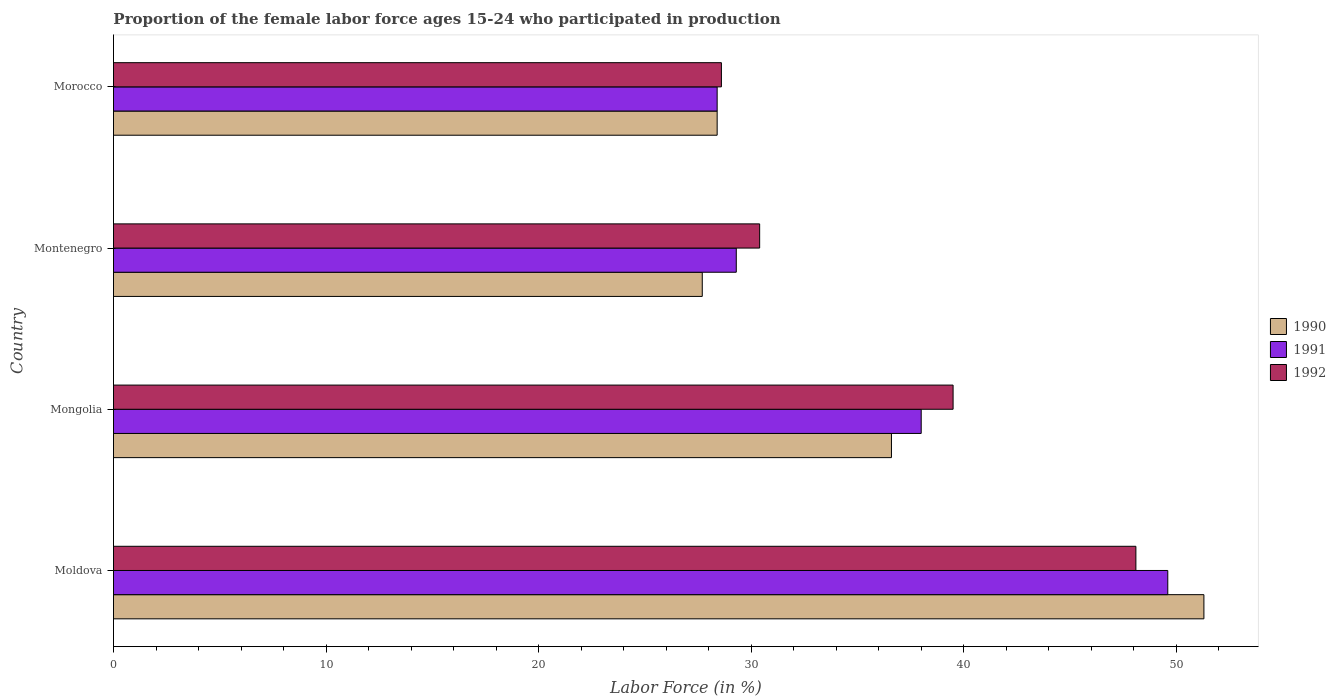Are the number of bars per tick equal to the number of legend labels?
Provide a short and direct response. Yes. Are the number of bars on each tick of the Y-axis equal?
Your answer should be compact. Yes. How many bars are there on the 1st tick from the bottom?
Your response must be concise. 3. What is the label of the 1st group of bars from the top?
Your answer should be compact. Morocco. In how many cases, is the number of bars for a given country not equal to the number of legend labels?
Keep it short and to the point. 0. What is the proportion of the female labor force who participated in production in 1990 in Mongolia?
Your answer should be very brief. 36.6. Across all countries, what is the maximum proportion of the female labor force who participated in production in 1992?
Your answer should be very brief. 48.1. Across all countries, what is the minimum proportion of the female labor force who participated in production in 1990?
Your response must be concise. 27.7. In which country was the proportion of the female labor force who participated in production in 1992 maximum?
Ensure brevity in your answer.  Moldova. In which country was the proportion of the female labor force who participated in production in 1992 minimum?
Keep it short and to the point. Morocco. What is the total proportion of the female labor force who participated in production in 1991 in the graph?
Your answer should be very brief. 145.3. What is the difference between the proportion of the female labor force who participated in production in 1992 in Mongolia and that in Montenegro?
Offer a very short reply. 9.1. What is the difference between the proportion of the female labor force who participated in production in 1992 in Mongolia and the proportion of the female labor force who participated in production in 1990 in Morocco?
Your response must be concise. 11.1. What is the average proportion of the female labor force who participated in production in 1990 per country?
Keep it short and to the point. 36. What is the difference between the proportion of the female labor force who participated in production in 1991 and proportion of the female labor force who participated in production in 1990 in Montenegro?
Make the answer very short. 1.6. In how many countries, is the proportion of the female labor force who participated in production in 1990 greater than 10 %?
Make the answer very short. 4. What is the ratio of the proportion of the female labor force who participated in production in 1992 in Montenegro to that in Morocco?
Provide a succinct answer. 1.06. What is the difference between the highest and the second highest proportion of the female labor force who participated in production in 1990?
Your response must be concise. 14.7. What is the difference between the highest and the lowest proportion of the female labor force who participated in production in 1992?
Your answer should be compact. 19.5. In how many countries, is the proportion of the female labor force who participated in production in 1990 greater than the average proportion of the female labor force who participated in production in 1990 taken over all countries?
Your answer should be very brief. 2. What does the 2nd bar from the bottom in Mongolia represents?
Keep it short and to the point. 1991. How many bars are there?
Provide a short and direct response. 12. How many countries are there in the graph?
Give a very brief answer. 4. Does the graph contain any zero values?
Ensure brevity in your answer.  No. Does the graph contain grids?
Offer a terse response. No. Where does the legend appear in the graph?
Your answer should be compact. Center right. What is the title of the graph?
Your answer should be compact. Proportion of the female labor force ages 15-24 who participated in production. Does "1988" appear as one of the legend labels in the graph?
Provide a succinct answer. No. What is the Labor Force (in %) of 1990 in Moldova?
Offer a very short reply. 51.3. What is the Labor Force (in %) in 1991 in Moldova?
Offer a terse response. 49.6. What is the Labor Force (in %) of 1992 in Moldova?
Your answer should be very brief. 48.1. What is the Labor Force (in %) of 1990 in Mongolia?
Keep it short and to the point. 36.6. What is the Labor Force (in %) in 1992 in Mongolia?
Your response must be concise. 39.5. What is the Labor Force (in %) in 1990 in Montenegro?
Offer a very short reply. 27.7. What is the Labor Force (in %) in 1991 in Montenegro?
Provide a short and direct response. 29.3. What is the Labor Force (in %) in 1992 in Montenegro?
Ensure brevity in your answer.  30.4. What is the Labor Force (in %) in 1990 in Morocco?
Keep it short and to the point. 28.4. What is the Labor Force (in %) in 1991 in Morocco?
Provide a succinct answer. 28.4. What is the Labor Force (in %) of 1992 in Morocco?
Offer a terse response. 28.6. Across all countries, what is the maximum Labor Force (in %) of 1990?
Provide a short and direct response. 51.3. Across all countries, what is the maximum Labor Force (in %) in 1991?
Provide a succinct answer. 49.6. Across all countries, what is the maximum Labor Force (in %) of 1992?
Make the answer very short. 48.1. Across all countries, what is the minimum Labor Force (in %) of 1990?
Offer a terse response. 27.7. Across all countries, what is the minimum Labor Force (in %) in 1991?
Keep it short and to the point. 28.4. Across all countries, what is the minimum Labor Force (in %) in 1992?
Make the answer very short. 28.6. What is the total Labor Force (in %) in 1990 in the graph?
Provide a short and direct response. 144. What is the total Labor Force (in %) of 1991 in the graph?
Keep it short and to the point. 145.3. What is the total Labor Force (in %) of 1992 in the graph?
Keep it short and to the point. 146.6. What is the difference between the Labor Force (in %) in 1990 in Moldova and that in Mongolia?
Your response must be concise. 14.7. What is the difference between the Labor Force (in %) of 1992 in Moldova and that in Mongolia?
Your response must be concise. 8.6. What is the difference between the Labor Force (in %) in 1990 in Moldova and that in Montenegro?
Ensure brevity in your answer.  23.6. What is the difference between the Labor Force (in %) of 1991 in Moldova and that in Montenegro?
Your answer should be compact. 20.3. What is the difference between the Labor Force (in %) of 1990 in Moldova and that in Morocco?
Your response must be concise. 22.9. What is the difference between the Labor Force (in %) in 1991 in Moldova and that in Morocco?
Offer a terse response. 21.2. What is the difference between the Labor Force (in %) of 1992 in Moldova and that in Morocco?
Your response must be concise. 19.5. What is the difference between the Labor Force (in %) of 1991 in Mongolia and that in Montenegro?
Your answer should be compact. 8.7. What is the difference between the Labor Force (in %) in 1992 in Mongolia and that in Montenegro?
Your answer should be compact. 9.1. What is the difference between the Labor Force (in %) of 1991 in Mongolia and that in Morocco?
Ensure brevity in your answer.  9.6. What is the difference between the Labor Force (in %) in 1992 in Montenegro and that in Morocco?
Ensure brevity in your answer.  1.8. What is the difference between the Labor Force (in %) in 1990 in Moldova and the Labor Force (in %) in 1991 in Mongolia?
Provide a succinct answer. 13.3. What is the difference between the Labor Force (in %) in 1990 in Moldova and the Labor Force (in %) in 1992 in Mongolia?
Give a very brief answer. 11.8. What is the difference between the Labor Force (in %) in 1990 in Moldova and the Labor Force (in %) in 1992 in Montenegro?
Ensure brevity in your answer.  20.9. What is the difference between the Labor Force (in %) of 1990 in Moldova and the Labor Force (in %) of 1991 in Morocco?
Ensure brevity in your answer.  22.9. What is the difference between the Labor Force (in %) of 1990 in Moldova and the Labor Force (in %) of 1992 in Morocco?
Provide a short and direct response. 22.7. What is the difference between the Labor Force (in %) of 1990 in Mongolia and the Labor Force (in %) of 1992 in Montenegro?
Your answer should be compact. 6.2. What is the difference between the Labor Force (in %) in 1990 in Montenegro and the Labor Force (in %) in 1991 in Morocco?
Offer a terse response. -0.7. What is the difference between the Labor Force (in %) in 1990 in Montenegro and the Labor Force (in %) in 1992 in Morocco?
Your answer should be very brief. -0.9. What is the difference between the Labor Force (in %) of 1991 in Montenegro and the Labor Force (in %) of 1992 in Morocco?
Offer a terse response. 0.7. What is the average Labor Force (in %) of 1990 per country?
Make the answer very short. 36. What is the average Labor Force (in %) of 1991 per country?
Offer a very short reply. 36.33. What is the average Labor Force (in %) in 1992 per country?
Provide a succinct answer. 36.65. What is the difference between the Labor Force (in %) of 1990 and Labor Force (in %) of 1991 in Moldova?
Give a very brief answer. 1.7. What is the difference between the Labor Force (in %) of 1991 and Labor Force (in %) of 1992 in Moldova?
Your answer should be compact. 1.5. What is the difference between the Labor Force (in %) in 1990 and Labor Force (in %) in 1991 in Mongolia?
Keep it short and to the point. -1.4. What is the difference between the Labor Force (in %) in 1990 and Labor Force (in %) in 1992 in Mongolia?
Provide a succinct answer. -2.9. What is the difference between the Labor Force (in %) of 1990 and Labor Force (in %) of 1992 in Montenegro?
Offer a very short reply. -2.7. What is the difference between the Labor Force (in %) of 1990 and Labor Force (in %) of 1991 in Morocco?
Make the answer very short. 0. What is the difference between the Labor Force (in %) in 1991 and Labor Force (in %) in 1992 in Morocco?
Keep it short and to the point. -0.2. What is the ratio of the Labor Force (in %) of 1990 in Moldova to that in Mongolia?
Offer a very short reply. 1.4. What is the ratio of the Labor Force (in %) in 1991 in Moldova to that in Mongolia?
Ensure brevity in your answer.  1.31. What is the ratio of the Labor Force (in %) of 1992 in Moldova to that in Mongolia?
Your answer should be compact. 1.22. What is the ratio of the Labor Force (in %) of 1990 in Moldova to that in Montenegro?
Provide a short and direct response. 1.85. What is the ratio of the Labor Force (in %) in 1991 in Moldova to that in Montenegro?
Provide a succinct answer. 1.69. What is the ratio of the Labor Force (in %) in 1992 in Moldova to that in Montenegro?
Give a very brief answer. 1.58. What is the ratio of the Labor Force (in %) of 1990 in Moldova to that in Morocco?
Your answer should be compact. 1.81. What is the ratio of the Labor Force (in %) in 1991 in Moldova to that in Morocco?
Provide a succinct answer. 1.75. What is the ratio of the Labor Force (in %) in 1992 in Moldova to that in Morocco?
Your answer should be compact. 1.68. What is the ratio of the Labor Force (in %) in 1990 in Mongolia to that in Montenegro?
Keep it short and to the point. 1.32. What is the ratio of the Labor Force (in %) in 1991 in Mongolia to that in Montenegro?
Ensure brevity in your answer.  1.3. What is the ratio of the Labor Force (in %) in 1992 in Mongolia to that in Montenegro?
Give a very brief answer. 1.3. What is the ratio of the Labor Force (in %) of 1990 in Mongolia to that in Morocco?
Keep it short and to the point. 1.29. What is the ratio of the Labor Force (in %) in 1991 in Mongolia to that in Morocco?
Your answer should be compact. 1.34. What is the ratio of the Labor Force (in %) in 1992 in Mongolia to that in Morocco?
Ensure brevity in your answer.  1.38. What is the ratio of the Labor Force (in %) in 1990 in Montenegro to that in Morocco?
Offer a terse response. 0.98. What is the ratio of the Labor Force (in %) in 1991 in Montenegro to that in Morocco?
Your response must be concise. 1.03. What is the ratio of the Labor Force (in %) of 1992 in Montenegro to that in Morocco?
Your answer should be compact. 1.06. What is the difference between the highest and the second highest Labor Force (in %) in 1992?
Make the answer very short. 8.6. What is the difference between the highest and the lowest Labor Force (in %) in 1990?
Keep it short and to the point. 23.6. What is the difference between the highest and the lowest Labor Force (in %) in 1991?
Provide a short and direct response. 21.2. What is the difference between the highest and the lowest Labor Force (in %) in 1992?
Make the answer very short. 19.5. 